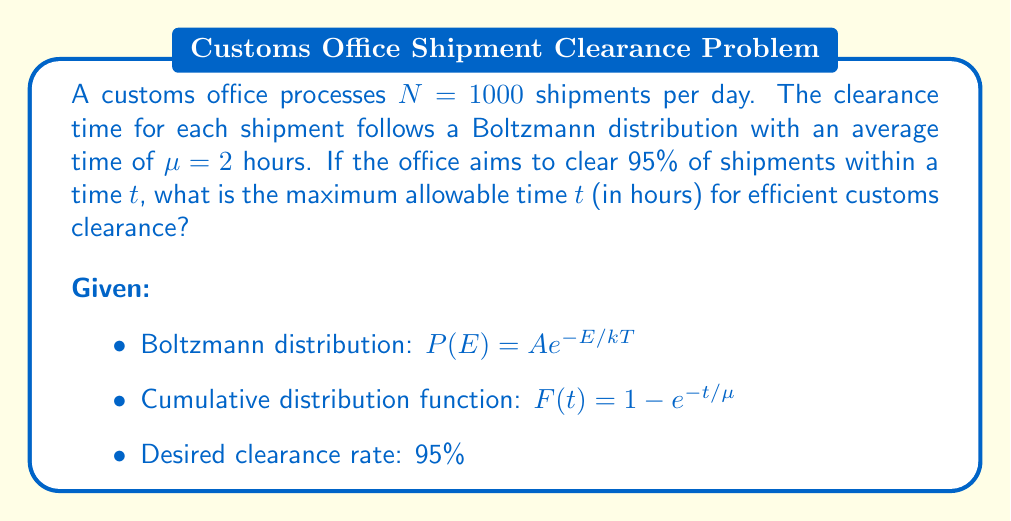Can you solve this math problem? 1) The cumulative distribution function (CDF) for the Boltzmann distribution is given by:

   $F(t) = 1 - e^{-t/\mu}$

2) We want to find $t$ such that 95% of shipments are cleared within this time:

   $F(t) = 0.95$

3) Substituting into the CDF equation:

   $0.95 = 1 - e^{-t/\mu}$

4) Rearranging the equation:

   $e^{-t/\mu} = 1 - 0.95 = 0.05$

5) Taking the natural logarithm of both sides:

   $-t/\mu = \ln(0.05)$

6) Solving for $t$:

   $t = -\mu \ln(0.05)$

7) Given $\mu = 2$ hours, we can calculate $t$:

   $t = -2 \ln(0.05) \approx 5.99$ hours

8) Rounding up to the nearest tenth of an hour for practical implementation:

   $t \approx 6.0$ hours
Answer: 6.0 hours 